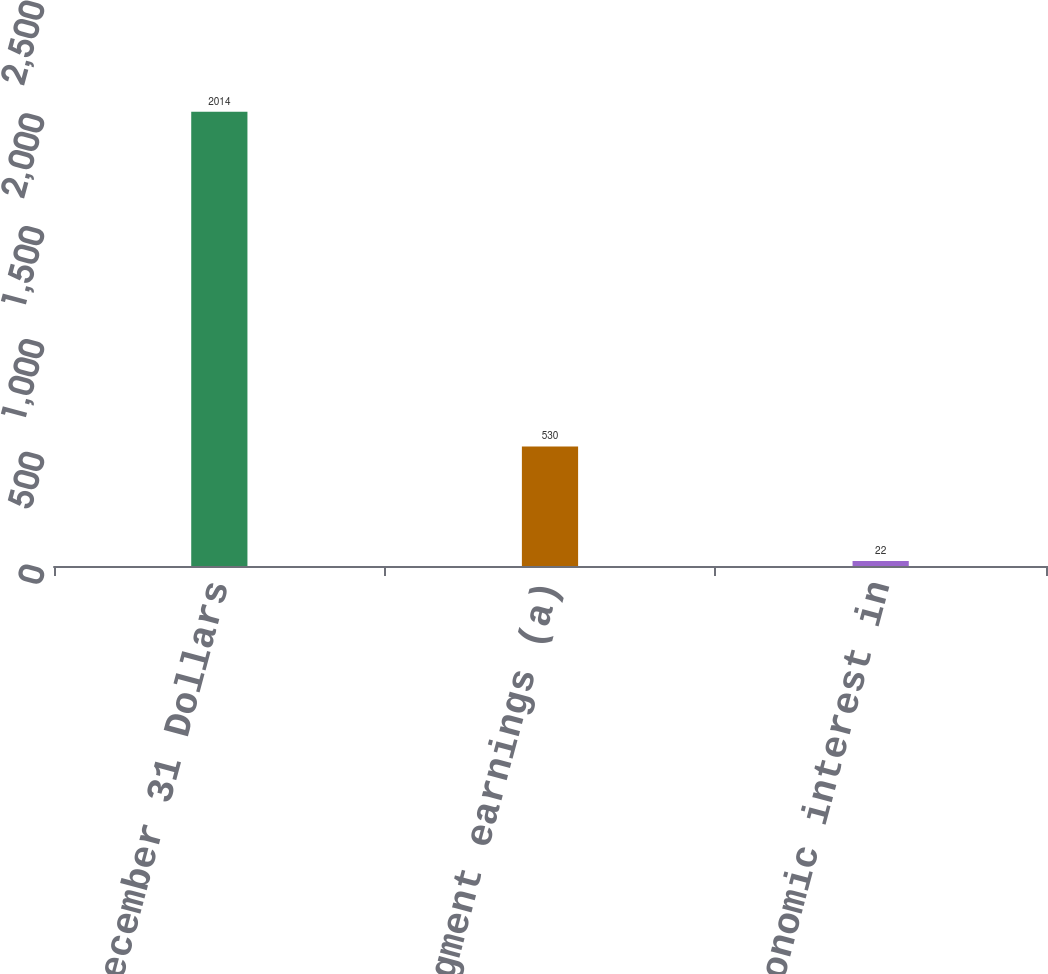Convert chart to OTSL. <chart><loc_0><loc_0><loc_500><loc_500><bar_chart><fcel>Year ended December 31 Dollars<fcel>Business segment earnings (a)<fcel>PNC's economic interest in<nl><fcel>2014<fcel>530<fcel>22<nl></chart> 